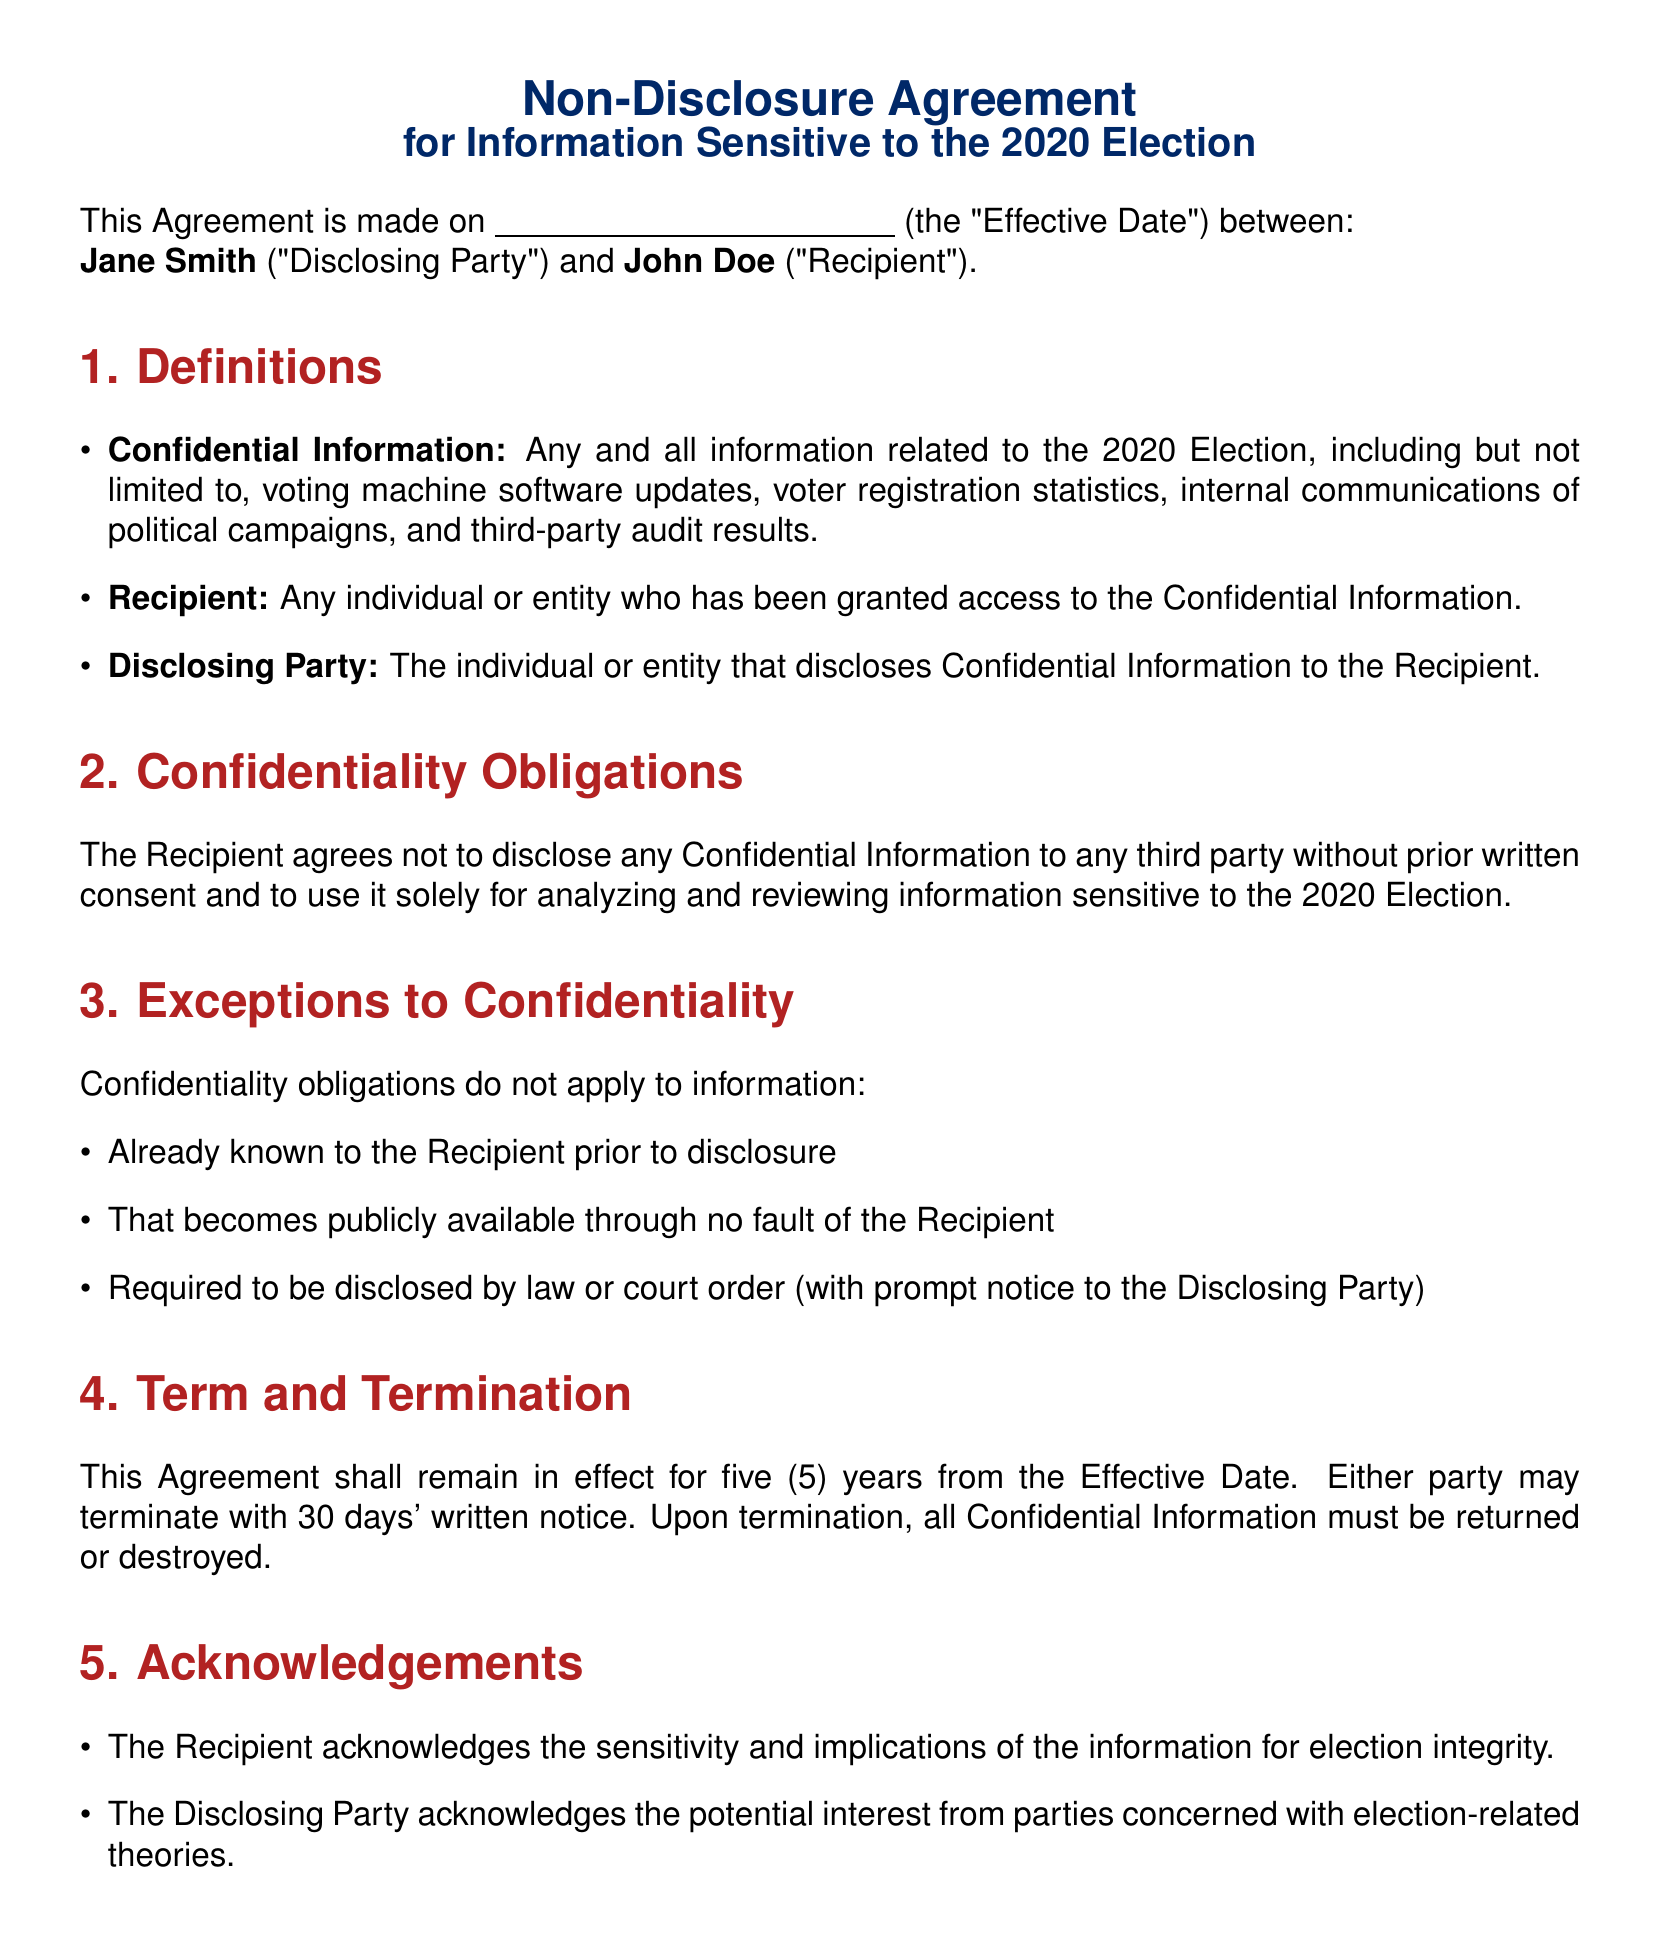What is the Effective Date of the Agreement? The Effective Date is specified as an empty field for Jane Smith and John Doe to fill in, indicating it's not provided in the document.
Answer: (field for date) Who is the Disclosing Party? The Disclosing Party is the individual in the agreement who reveals the Confidential Information. According to the document, it is Jane Smith.
Answer: Jane Smith How long is the agreement valid? The duration of the agreement is stated in the Term section, indicating it shall remain in effect for five years.
Answer: five years What must the Recipient do with Confidential Information upon termination? The document specifies that upon termination, the Recipient must either return or destroy all Confidential Information.
Answer: return or destroy What law governs this Agreement? The document identifies the governing law for the Agreement, which is specified in the Miscellaneous section.
Answer: Florida law What type of information is classified as Confidential Information? The document lists types of information that are considered confidential, including voting machine software updates, voter registration statistics, and more.
Answer: Any information related to the 2020 Election What option does either party have for terminating the Agreement? The document specifies that either party may terminate the Agreement with 30 days' written notice.
Answer: 30 days' written notice What is the primary purpose of the Recipient accessing the information? The document states the Recipient agrees to use the Confidential Information solely for analyzing and reviewing information sensitive to the 2020 Election.
Answer: analyzing and reviewing information sensitive to the 2020 Election What is one exception to the confidentiality obligations? The document outlines three exceptions, one of which is that confidentiality obligations do not apply to information that becomes publicly available through no fault of the Recipient.
Answer: publicly available information 